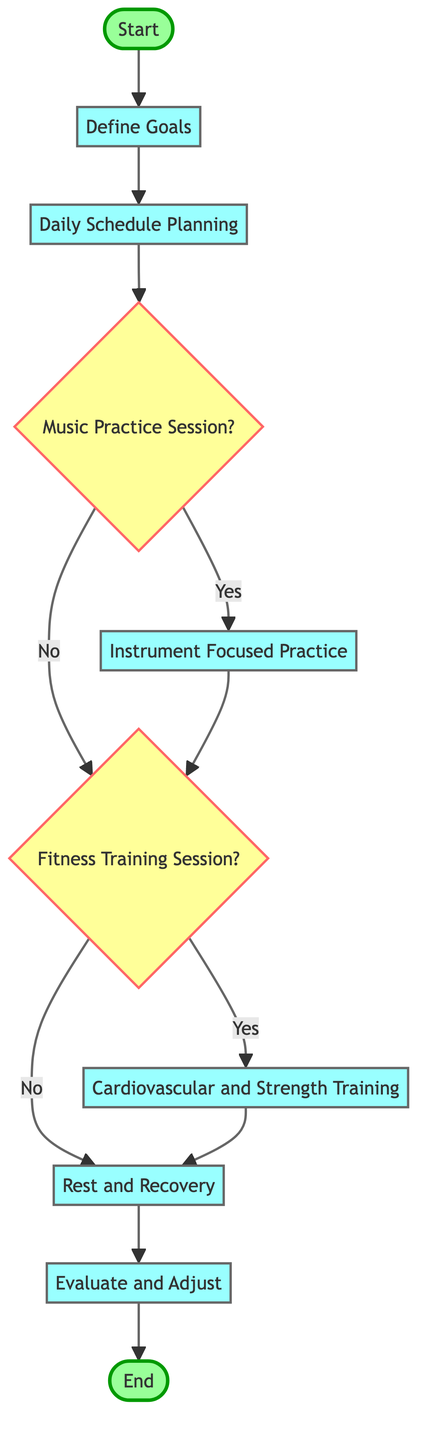What is the starting point of the diagram? The starting point is denoted by the node labeled "Start," which is the first element in the flow chart.
Answer: Start How many decision nodes are present in the diagram? There are two decision nodes in the diagram, specifically labeled "Music Practice Session?" and "Fitness Training Session?"
Answer: 2 What is the last process before the end of the flow? The last process before reaching the end is "Evaluate and Adjust," as it is the final action taken before concluding the function.
Answer: Evaluate and Adjust What comes after "Daily Schedule Planning"? Following "Daily Schedule Planning," the next node is "Music Practice Session," which is the subsequent step in the process flow.
Answer: Music Practice Session What happens if the "Fitness Training Session?" decision is answered with "No"? If the answer to the "Fitness Training Session?" is "No," the flow chart indicates the next step is "Rest and Recovery," leading to the scheduling of recovery before proceeding to the evaluation stage.
Answer: Rest and Recovery In which step do you focus on the instrument during practice? The focus on the instrument occurs in the step labeled "Instrument Focused Practice," where dedicated time is allocated for specific instrument training.
Answer: Instrument Focused Practice What type of training is emphasized in step seven? Step seven emphasizes "Cardiovascular and Strength Training," indicating that the focus is on improving endurance and physical strength for racing.
Answer: Cardiovascular and Strength Training What is the function's endpoint? The function's endpoint is designated as "End," which signifies the completion of the process flow depicted in the diagram.
Answer: End 